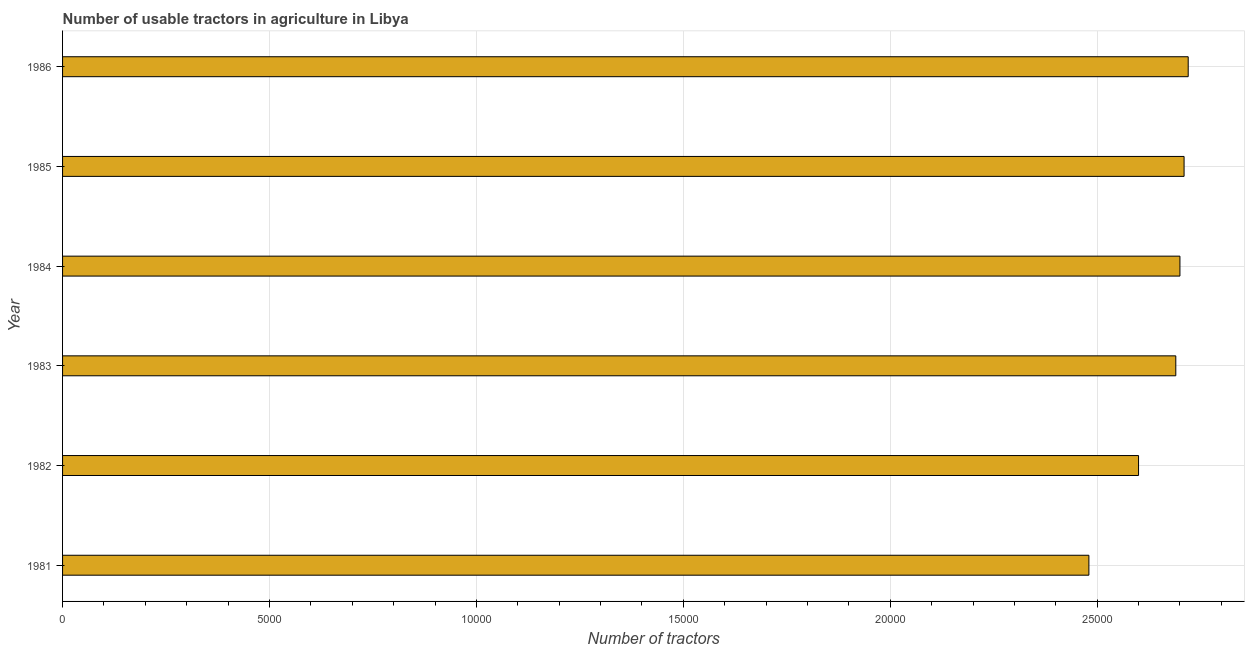Does the graph contain grids?
Your answer should be compact. Yes. What is the title of the graph?
Your answer should be compact. Number of usable tractors in agriculture in Libya. What is the label or title of the X-axis?
Your answer should be compact. Number of tractors. What is the number of tractors in 1983?
Ensure brevity in your answer.  2.69e+04. Across all years, what is the maximum number of tractors?
Provide a succinct answer. 2.72e+04. Across all years, what is the minimum number of tractors?
Keep it short and to the point. 2.48e+04. In which year was the number of tractors minimum?
Offer a very short reply. 1981. What is the sum of the number of tractors?
Keep it short and to the point. 1.59e+05. What is the difference between the number of tractors in 1984 and 1986?
Provide a short and direct response. -200. What is the average number of tractors per year?
Offer a very short reply. 2.65e+04. What is the median number of tractors?
Your response must be concise. 2.70e+04. Do a majority of the years between 1985 and 1982 (inclusive) have number of tractors greater than 26000 ?
Make the answer very short. Yes. What is the ratio of the number of tractors in 1982 to that in 1985?
Your answer should be compact. 0.96. Is the number of tractors in 1981 less than that in 1983?
Make the answer very short. Yes. Is the difference between the number of tractors in 1981 and 1985 greater than the difference between any two years?
Make the answer very short. No. What is the difference between the highest and the second highest number of tractors?
Offer a terse response. 100. Is the sum of the number of tractors in 1981 and 1983 greater than the maximum number of tractors across all years?
Your answer should be very brief. Yes. What is the difference between the highest and the lowest number of tractors?
Your answer should be very brief. 2400. How many bars are there?
Make the answer very short. 6. Are all the bars in the graph horizontal?
Provide a short and direct response. Yes. How many years are there in the graph?
Provide a succinct answer. 6. What is the difference between two consecutive major ticks on the X-axis?
Your answer should be compact. 5000. Are the values on the major ticks of X-axis written in scientific E-notation?
Make the answer very short. No. What is the Number of tractors of 1981?
Offer a terse response. 2.48e+04. What is the Number of tractors of 1982?
Offer a very short reply. 2.60e+04. What is the Number of tractors in 1983?
Your answer should be compact. 2.69e+04. What is the Number of tractors in 1984?
Provide a short and direct response. 2.70e+04. What is the Number of tractors of 1985?
Provide a short and direct response. 2.71e+04. What is the Number of tractors of 1986?
Your answer should be very brief. 2.72e+04. What is the difference between the Number of tractors in 1981 and 1982?
Your response must be concise. -1200. What is the difference between the Number of tractors in 1981 and 1983?
Make the answer very short. -2100. What is the difference between the Number of tractors in 1981 and 1984?
Provide a short and direct response. -2200. What is the difference between the Number of tractors in 1981 and 1985?
Provide a short and direct response. -2300. What is the difference between the Number of tractors in 1981 and 1986?
Your answer should be very brief. -2400. What is the difference between the Number of tractors in 1982 and 1983?
Your response must be concise. -900. What is the difference between the Number of tractors in 1982 and 1984?
Offer a very short reply. -1000. What is the difference between the Number of tractors in 1982 and 1985?
Your answer should be very brief. -1100. What is the difference between the Number of tractors in 1982 and 1986?
Make the answer very short. -1200. What is the difference between the Number of tractors in 1983 and 1984?
Your response must be concise. -100. What is the difference between the Number of tractors in 1983 and 1985?
Keep it short and to the point. -200. What is the difference between the Number of tractors in 1983 and 1986?
Keep it short and to the point. -300. What is the difference between the Number of tractors in 1984 and 1985?
Offer a very short reply. -100. What is the difference between the Number of tractors in 1984 and 1986?
Offer a terse response. -200. What is the difference between the Number of tractors in 1985 and 1986?
Give a very brief answer. -100. What is the ratio of the Number of tractors in 1981 to that in 1982?
Make the answer very short. 0.95. What is the ratio of the Number of tractors in 1981 to that in 1983?
Provide a short and direct response. 0.92. What is the ratio of the Number of tractors in 1981 to that in 1984?
Keep it short and to the point. 0.92. What is the ratio of the Number of tractors in 1981 to that in 1985?
Give a very brief answer. 0.92. What is the ratio of the Number of tractors in 1981 to that in 1986?
Give a very brief answer. 0.91. What is the ratio of the Number of tractors in 1982 to that in 1983?
Offer a very short reply. 0.97. What is the ratio of the Number of tractors in 1982 to that in 1984?
Offer a terse response. 0.96. What is the ratio of the Number of tractors in 1982 to that in 1985?
Your answer should be compact. 0.96. What is the ratio of the Number of tractors in 1982 to that in 1986?
Offer a terse response. 0.96. What is the ratio of the Number of tractors in 1984 to that in 1985?
Make the answer very short. 1. What is the ratio of the Number of tractors in 1984 to that in 1986?
Your answer should be compact. 0.99. What is the ratio of the Number of tractors in 1985 to that in 1986?
Make the answer very short. 1. 